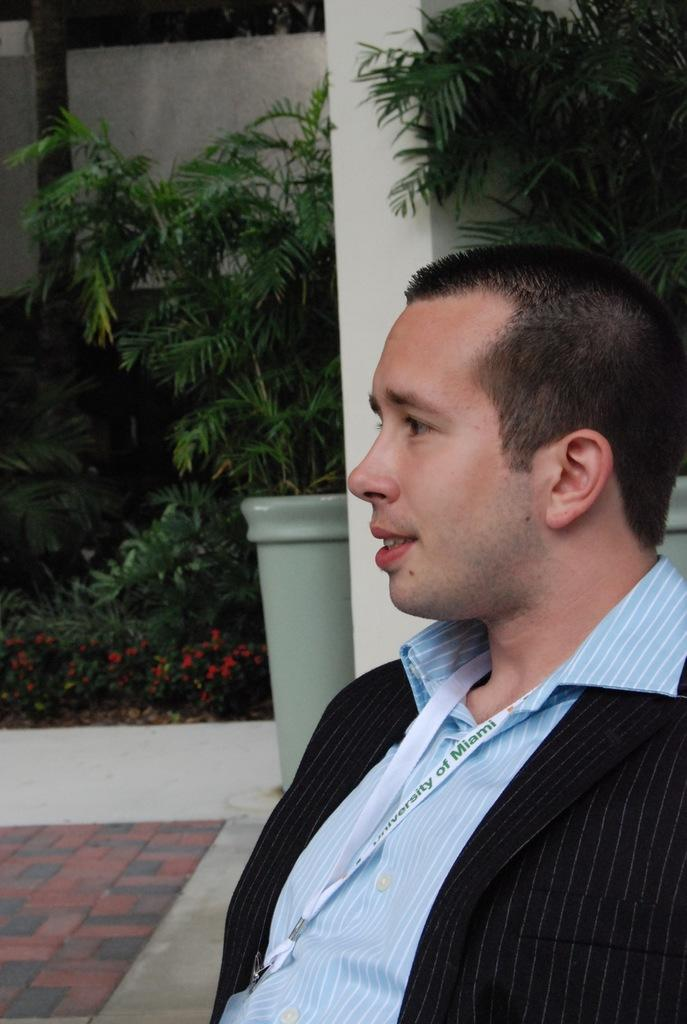What is the person in the image doing? The person is sitting in the image. What is the person wearing on their upper body? The person is wearing a black blazer and a blue color shirt. What can be seen in the background of the image? There are plants in the background of the image. What is the color of the plants? The plants are green in color. What is the color of the wall in the image? The wall is white in color. How many icicles are hanging from the person's chin in the image? There are no icicles present in the image, and the person's chin is not mentioned in the facts provided. 